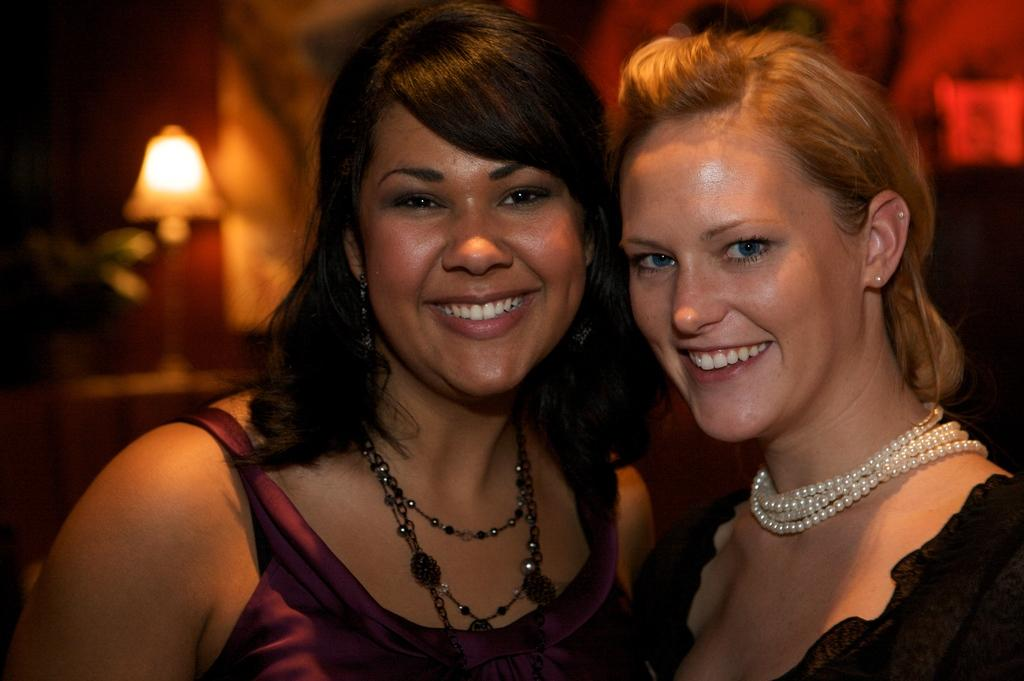How many people are in the image? There are two women in the image. What is the facial expression of the women? The women are smiling. Can you describe the background of the image? The background of the image is blurry. What object can be seen in the background? There is a lamp visible in the background of the image. What type of star can be seen in the image? There is no star visible in the image; it is an indoor scene with a blurry background and a lamp. What type of sponge is being used by the women in the image? There is no sponge present in the image; the women are simply smiling and there is no indication of any activity involving a sponge. 